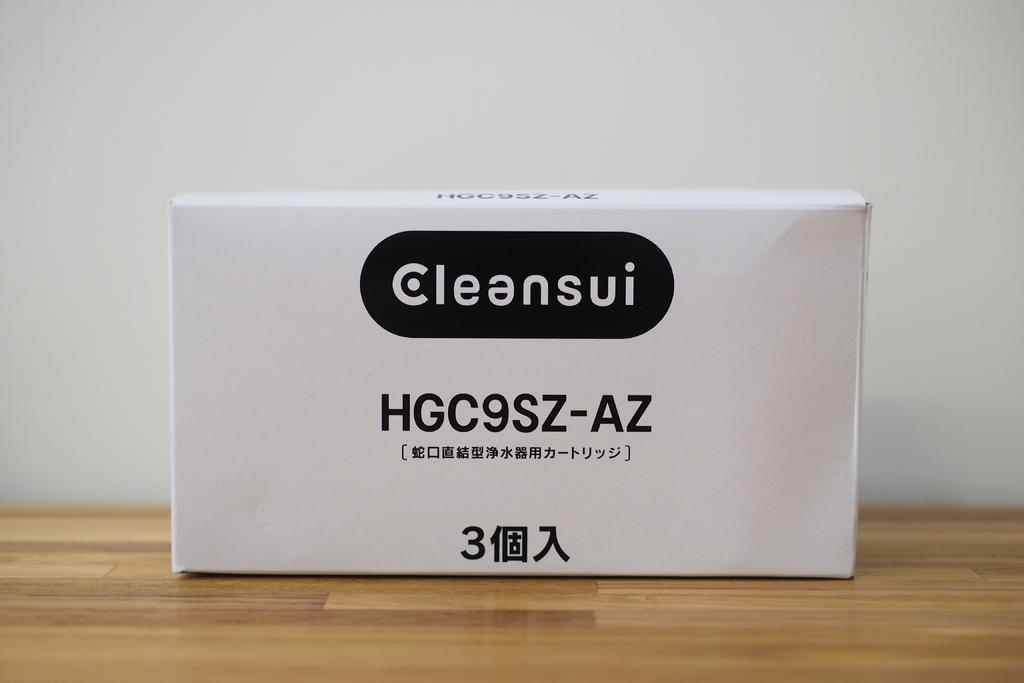Provide a one-sentence caption for the provided image. white box labeled Cleansui HGC9SZ-AZ on a wood floor. 